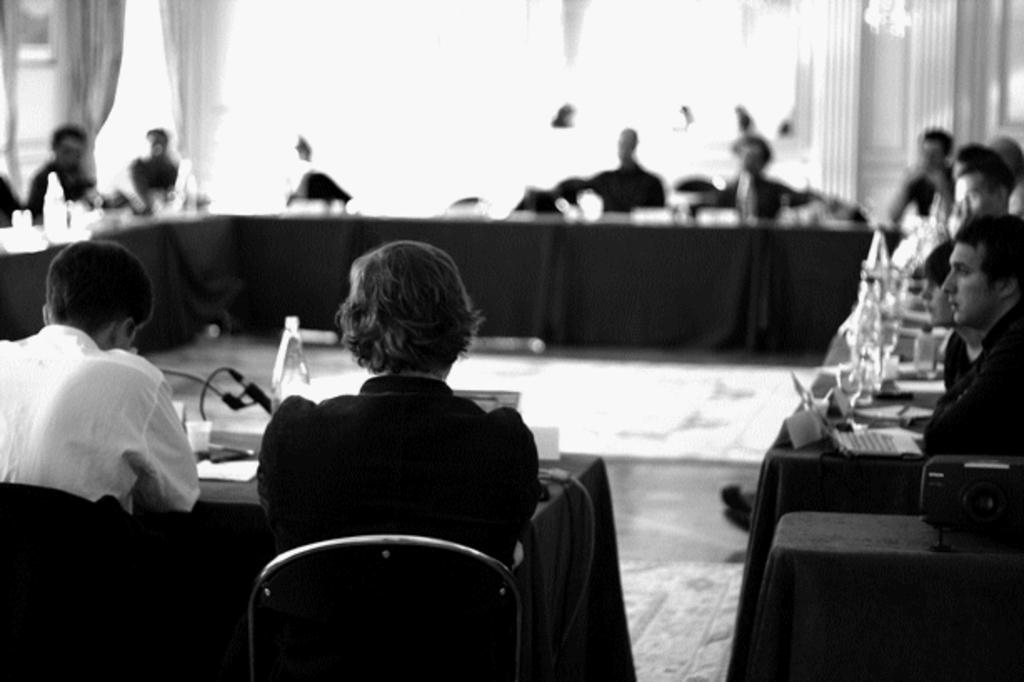What are the people in the image doing? The people in the image are sitting on chairs. What is located in front of the chairs? There is a table in front of the chairs. What can be seen on the table? There are products on the table. How does the beggar interact with the wilderness in the image? There is no beggar or wilderness present in the image. Can you describe the direction in which the table turns in the image? The table does not turn in the image; it is stationary. 